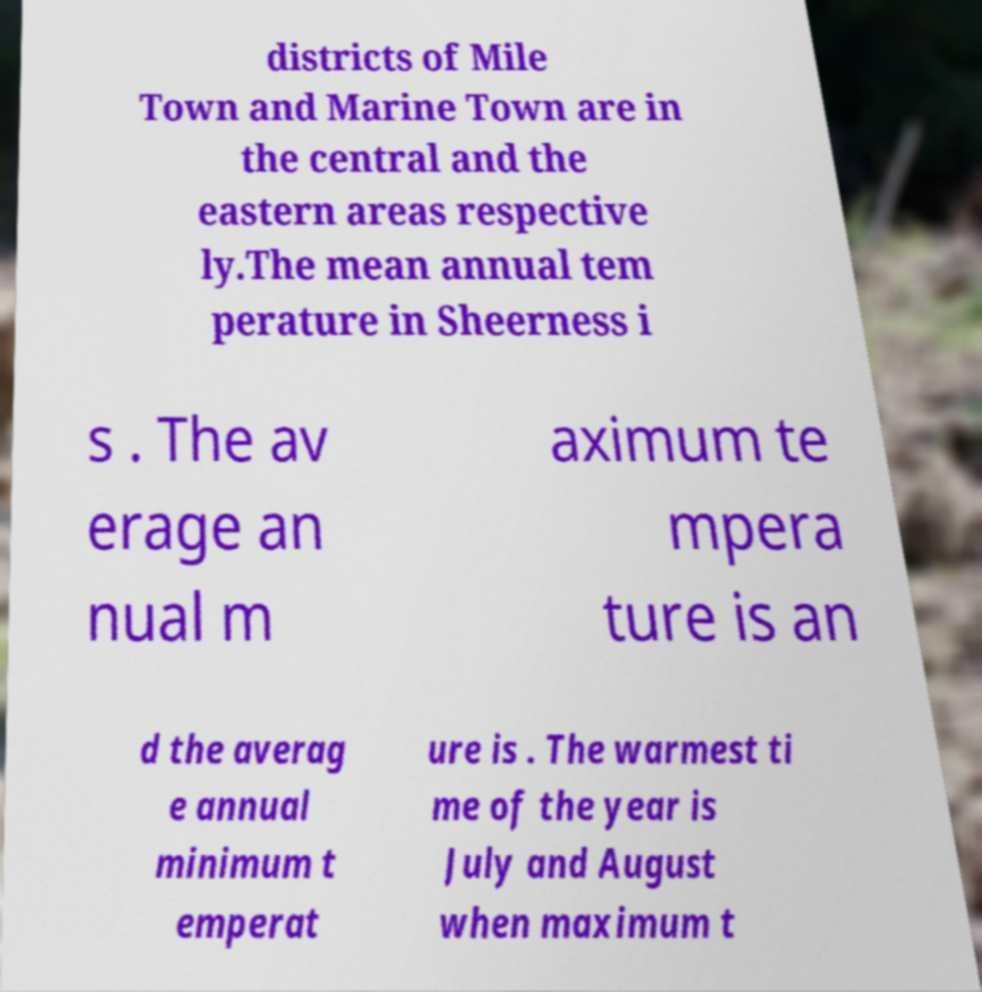Could you assist in decoding the text presented in this image and type it out clearly? districts of Mile Town and Marine Town are in the central and the eastern areas respective ly.The mean annual tem perature in Sheerness i s . The av erage an nual m aximum te mpera ture is an d the averag e annual minimum t emperat ure is . The warmest ti me of the year is July and August when maximum t 